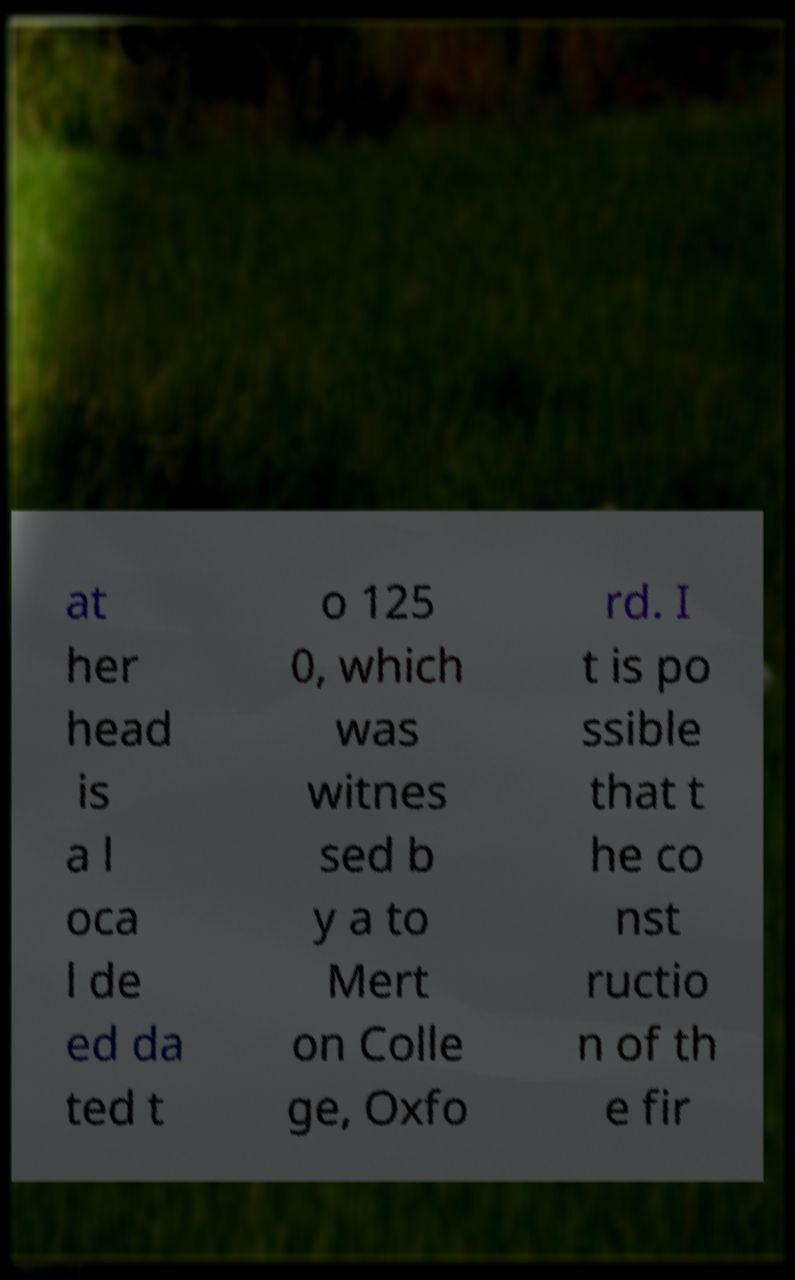What messages or text are displayed in this image? I need them in a readable, typed format. at her head is a l oca l de ed da ted t o 125 0, which was witnes sed b y a to Mert on Colle ge, Oxfo rd. I t is po ssible that t he co nst ructio n of th e fir 